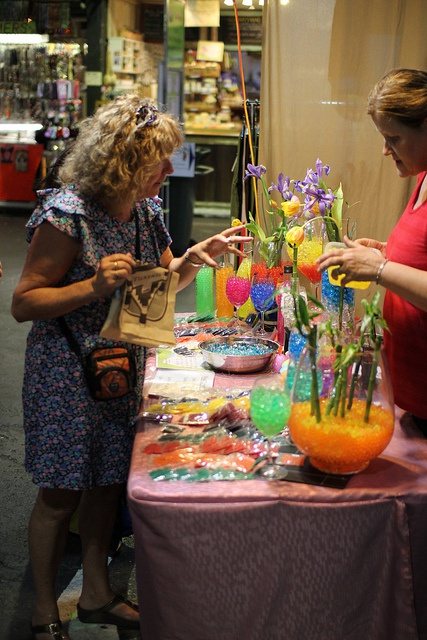Describe the objects in this image and their specific colors. I can see dining table in black, brown, and lightpink tones, people in black, maroon, and gray tones, people in black, maroon, gray, and tan tones, bowl in black, red, orange, olive, and maroon tones, and vase in black, red, orange, olive, and maroon tones in this image. 